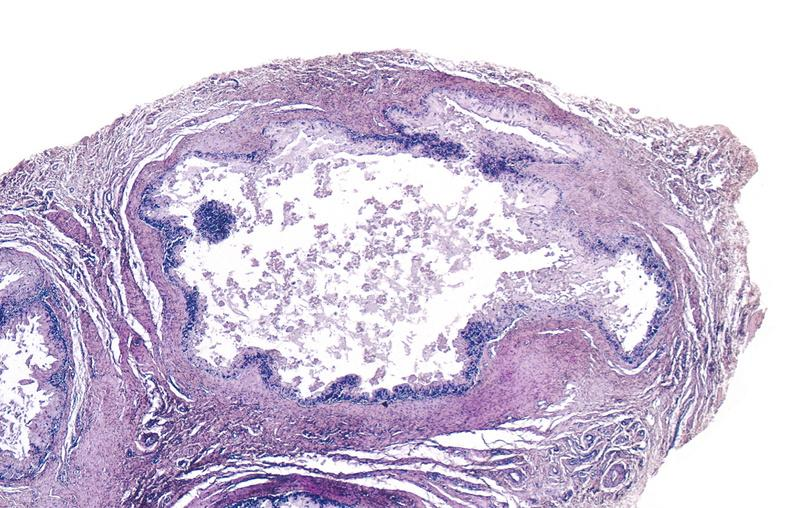s joints present?
Answer the question using a single word or phrase. Yes 